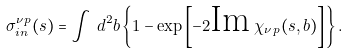<formula> <loc_0><loc_0><loc_500><loc_500>\sigma ^ { \nu p } _ { i n } ( s ) = \int \, d ^ { 2 } b \left \{ 1 - \exp \left [ - 2 \text {Im} \, \chi _ { \nu \, p } ( s , b ) \right ] \right \} .</formula> 